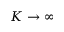Convert formula to latex. <formula><loc_0><loc_0><loc_500><loc_500>K \rightarrow \infty</formula> 